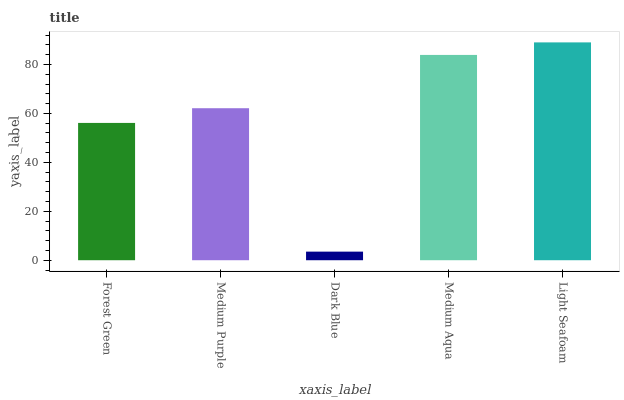Is Dark Blue the minimum?
Answer yes or no. Yes. Is Light Seafoam the maximum?
Answer yes or no. Yes. Is Medium Purple the minimum?
Answer yes or no. No. Is Medium Purple the maximum?
Answer yes or no. No. Is Medium Purple greater than Forest Green?
Answer yes or no. Yes. Is Forest Green less than Medium Purple?
Answer yes or no. Yes. Is Forest Green greater than Medium Purple?
Answer yes or no. No. Is Medium Purple less than Forest Green?
Answer yes or no. No. Is Medium Purple the high median?
Answer yes or no. Yes. Is Medium Purple the low median?
Answer yes or no. Yes. Is Light Seafoam the high median?
Answer yes or no. No. Is Forest Green the low median?
Answer yes or no. No. 